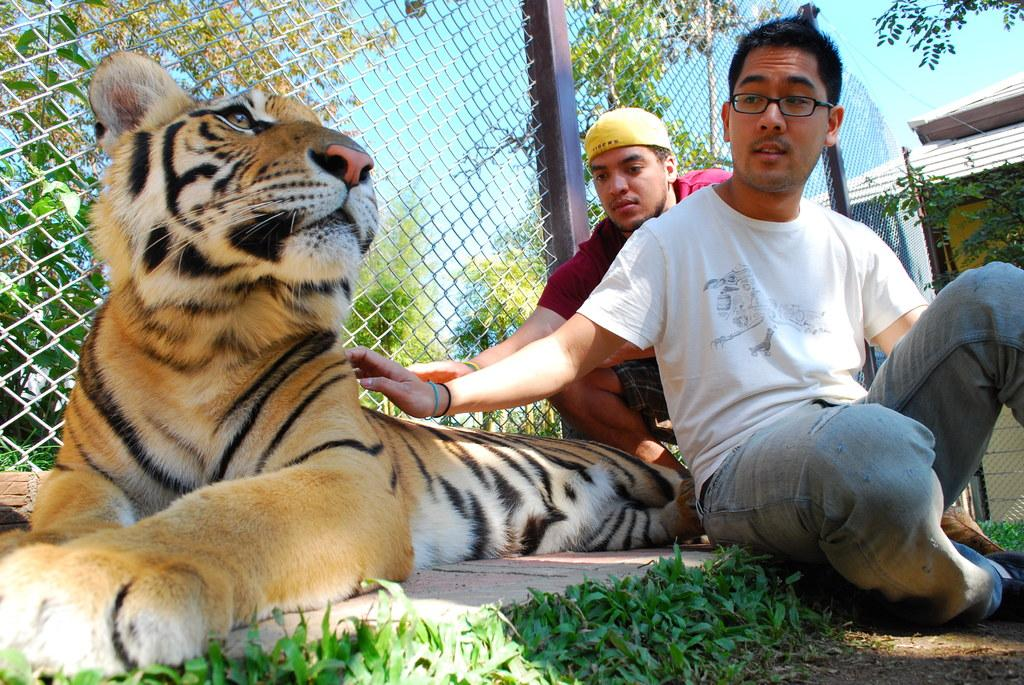How many people are in the image? There are two people in the image. Where are the two people located in the image? The two people are sitting on the right side. What other animal is present in the image besides the people? There is a tiger in the image. What is the position of the tiger in the image? The tiger is sitting on the ground. What type of pump can be seen in the image? There is no pump present in the image. How many minutes does it take for the donkey to walk across the image? There is no donkey present in the image, so it's not possible to determine how long it would take for it to walk across the image. 